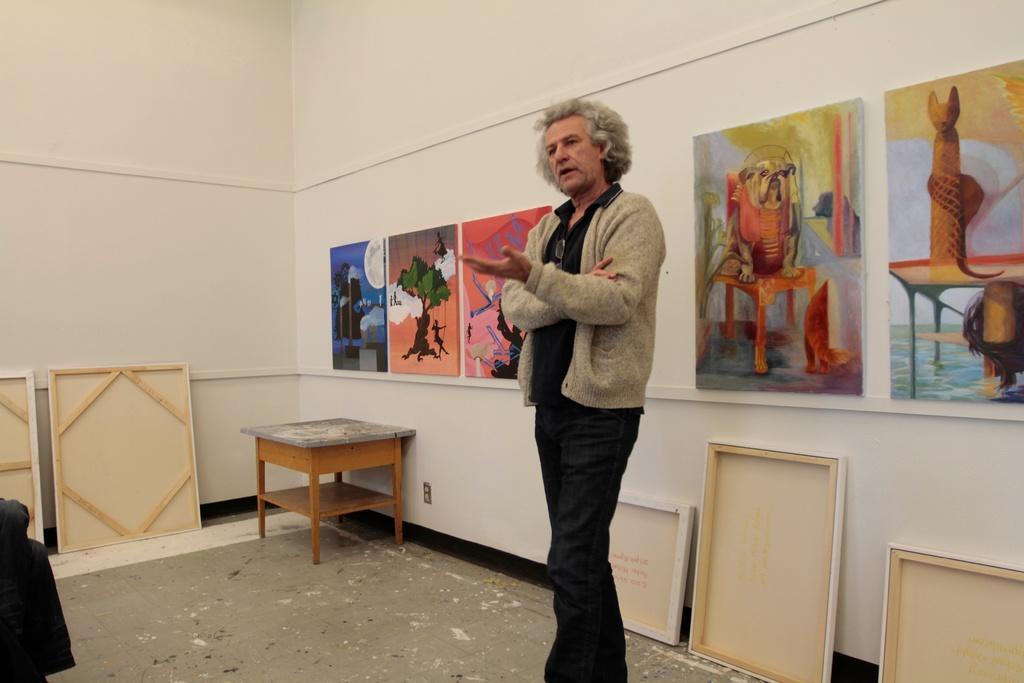Please provide a concise description of this image. There is a person standing in this picture in the room. There is a table and some photographs attached to the wall here in the background. 